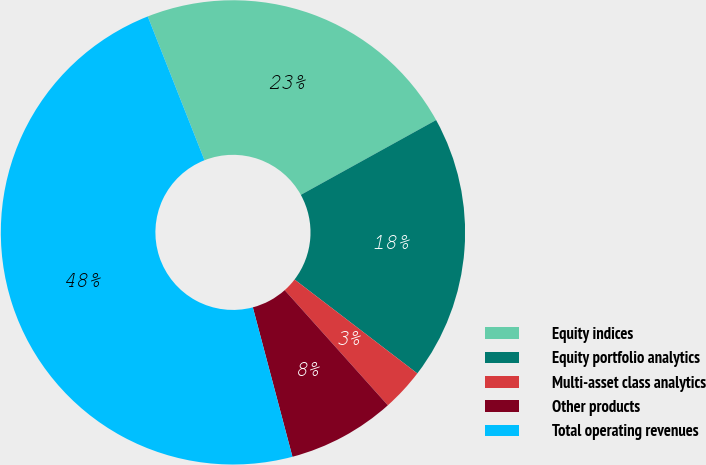Convert chart. <chart><loc_0><loc_0><loc_500><loc_500><pie_chart><fcel>Equity indices<fcel>Equity portfolio analytics<fcel>Multi-asset class analytics<fcel>Other products<fcel>Total operating revenues<nl><fcel>22.94%<fcel>18.43%<fcel>2.98%<fcel>7.5%<fcel>48.14%<nl></chart> 